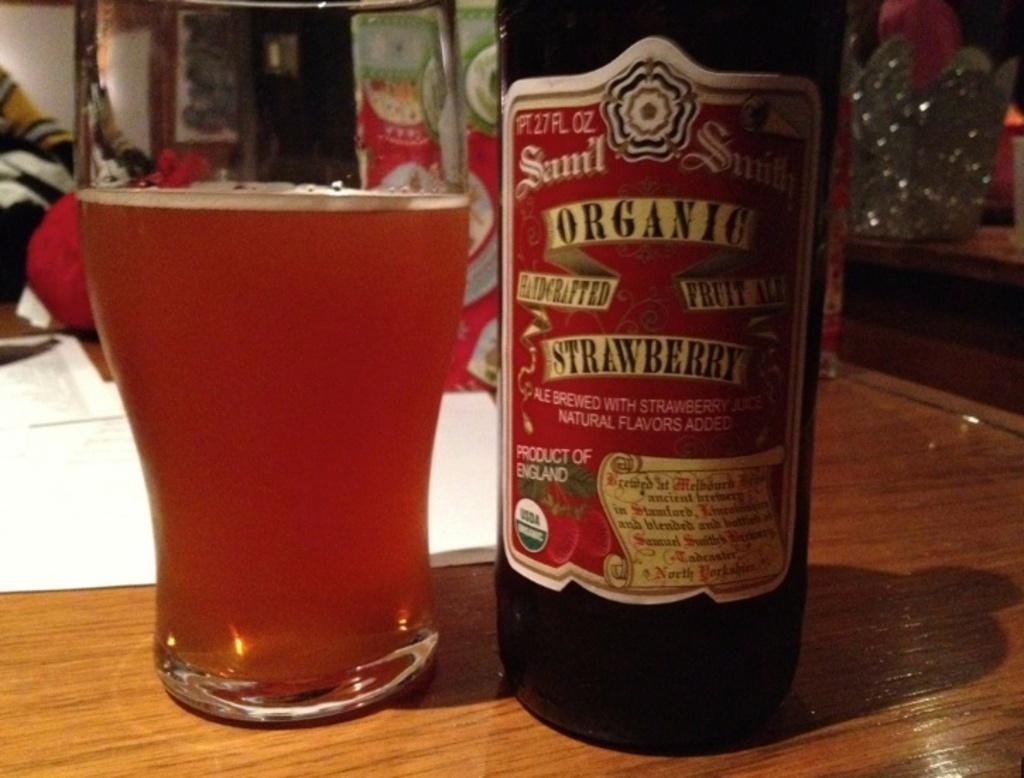Provide a one-sentence caption for the provided image. An organic strawberry bottle of ale is poured into a glass. 